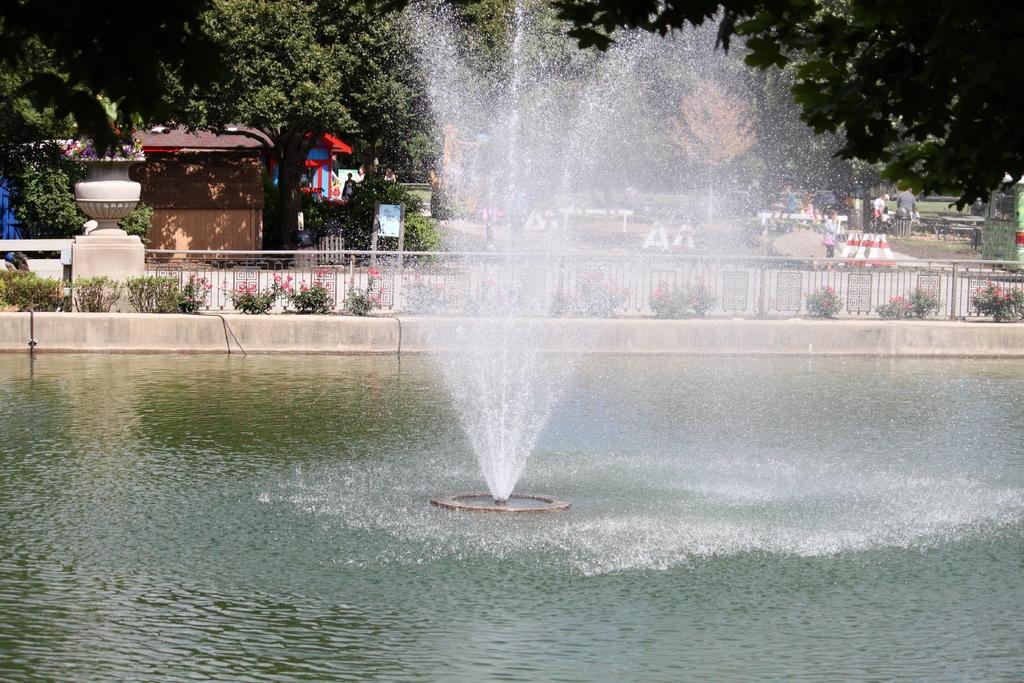Please provide a concise description of this image. As we can see in the image there is water, fountain, plants, trees, houses and few people here and there. 